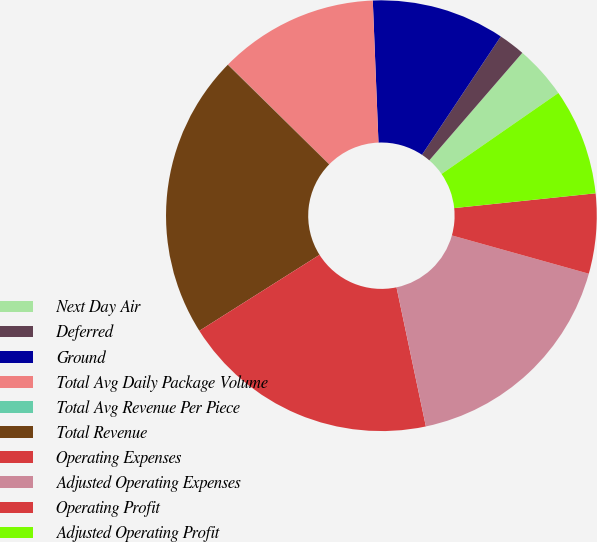<chart> <loc_0><loc_0><loc_500><loc_500><pie_chart><fcel>Next Day Air<fcel>Deferred<fcel>Ground<fcel>Total Avg Daily Package Volume<fcel>Total Avg Revenue Per Piece<fcel>Total Revenue<fcel>Operating Expenses<fcel>Adjusted Operating Expenses<fcel>Operating Profit<fcel>Adjusted Operating Profit<nl><fcel>4.0%<fcel>2.0%<fcel>9.99%<fcel>11.99%<fcel>0.01%<fcel>21.34%<fcel>19.34%<fcel>17.35%<fcel>6.0%<fcel>7.99%<nl></chart> 